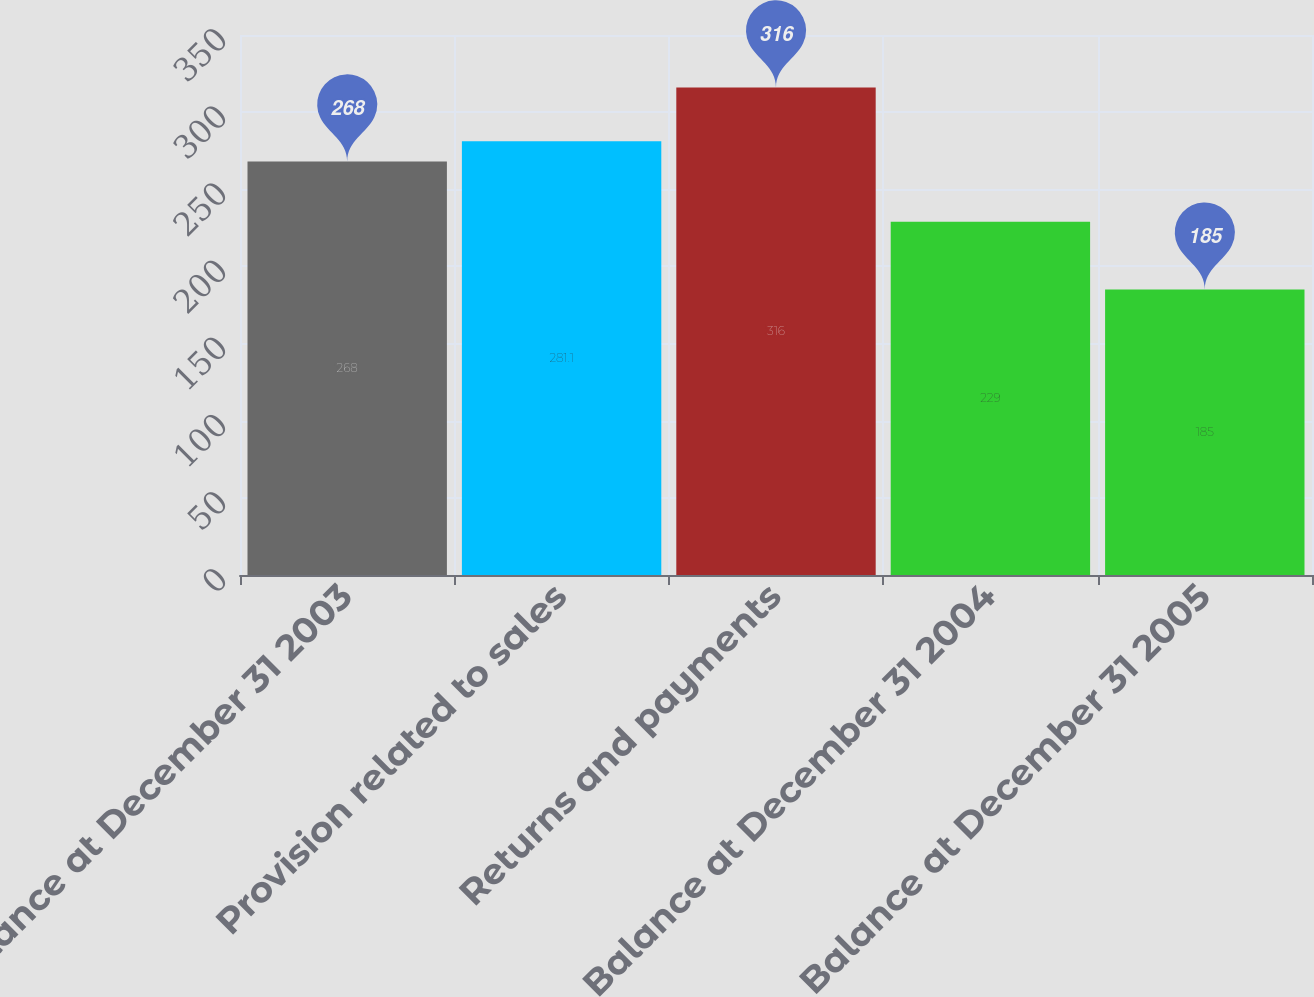Convert chart. <chart><loc_0><loc_0><loc_500><loc_500><bar_chart><fcel>Balance at December 31 2003<fcel>Provision related to sales<fcel>Returns and payments<fcel>Balance at December 31 2004<fcel>Balance at December 31 2005<nl><fcel>268<fcel>281.1<fcel>316<fcel>229<fcel>185<nl></chart> 